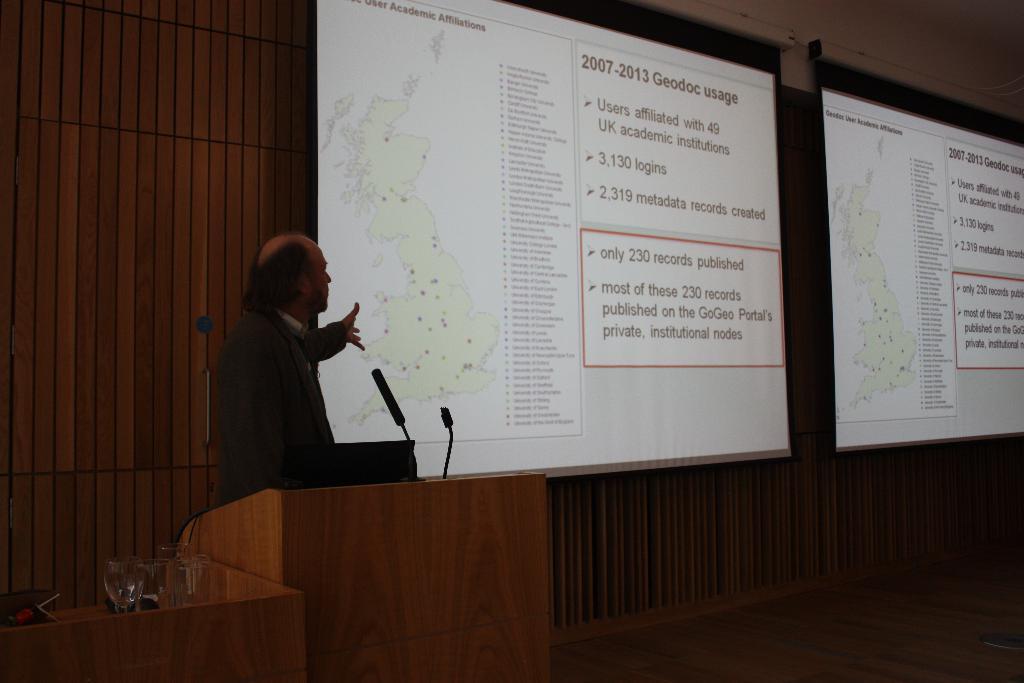How would you summarize this image in a sentence or two? This picture seems to be clicked inside the hall. On the left we can see a person wearing blazer and standing behind the wooden podium and we can see the microphones, glasses and some objects. In the background we can see the text and some pictures on the projector screens and we can see the wall and some object seems to be the curtain and we can see some other objects. 